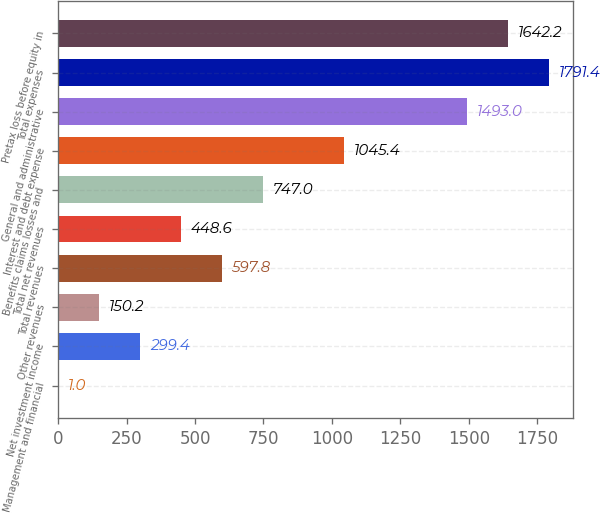<chart> <loc_0><loc_0><loc_500><loc_500><bar_chart><fcel>Management and financial<fcel>Net investment income<fcel>Other revenues<fcel>Total revenues<fcel>Total net revenues<fcel>Benefits claims losses and<fcel>Interest and debt expense<fcel>General and administrative<fcel>Total expenses<fcel>Pretax loss before equity in<nl><fcel>1<fcel>299.4<fcel>150.2<fcel>597.8<fcel>448.6<fcel>747<fcel>1045.4<fcel>1493<fcel>1791.4<fcel>1642.2<nl></chart> 